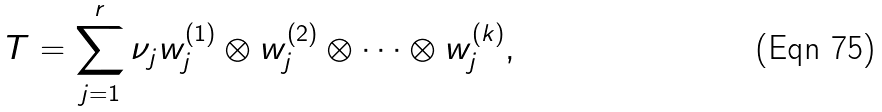<formula> <loc_0><loc_0><loc_500><loc_500>T = \sum _ { j = 1 } ^ { r } \nu _ { j } w _ { j } ^ { ( 1 ) } \otimes w _ { j } ^ { ( 2 ) } \otimes \cdots \otimes w _ { j } ^ { ( k ) } ,</formula> 